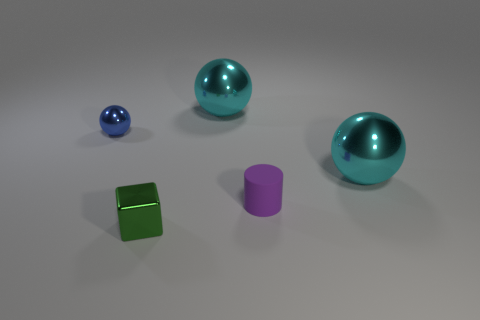Subtract all cyan balls. How many balls are left? 1 Add 4 small rubber things. How many objects exist? 9 Subtract all balls. How many objects are left? 2 Subtract 2 spheres. How many spheres are left? 1 Subtract all brown blocks. How many blue spheres are left? 1 Subtract all purple rubber objects. Subtract all purple objects. How many objects are left? 3 Add 2 big metallic spheres. How many big metallic spheres are left? 4 Add 3 cyan balls. How many cyan balls exist? 5 Subtract all cyan spheres. How many spheres are left? 1 Subtract 0 brown blocks. How many objects are left? 5 